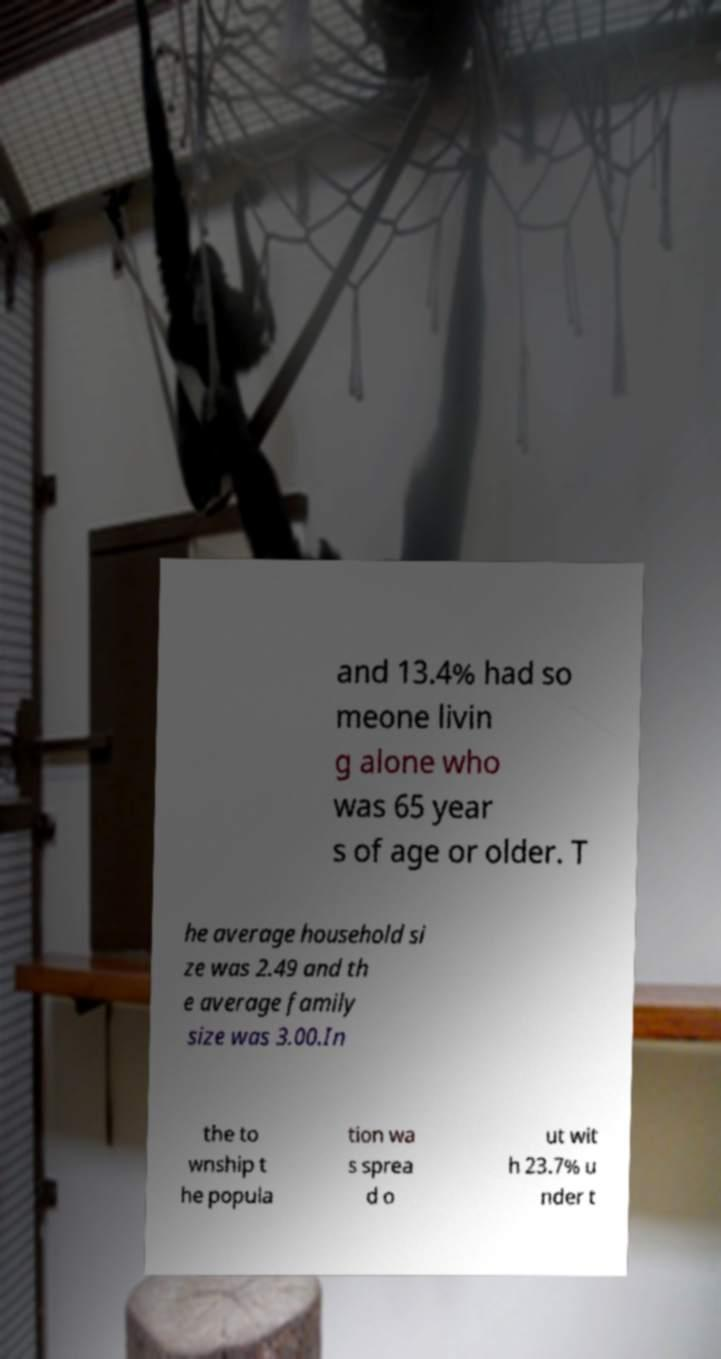Can you accurately transcribe the text from the provided image for me? and 13.4% had so meone livin g alone who was 65 year s of age or older. T he average household si ze was 2.49 and th e average family size was 3.00.In the to wnship t he popula tion wa s sprea d o ut wit h 23.7% u nder t 